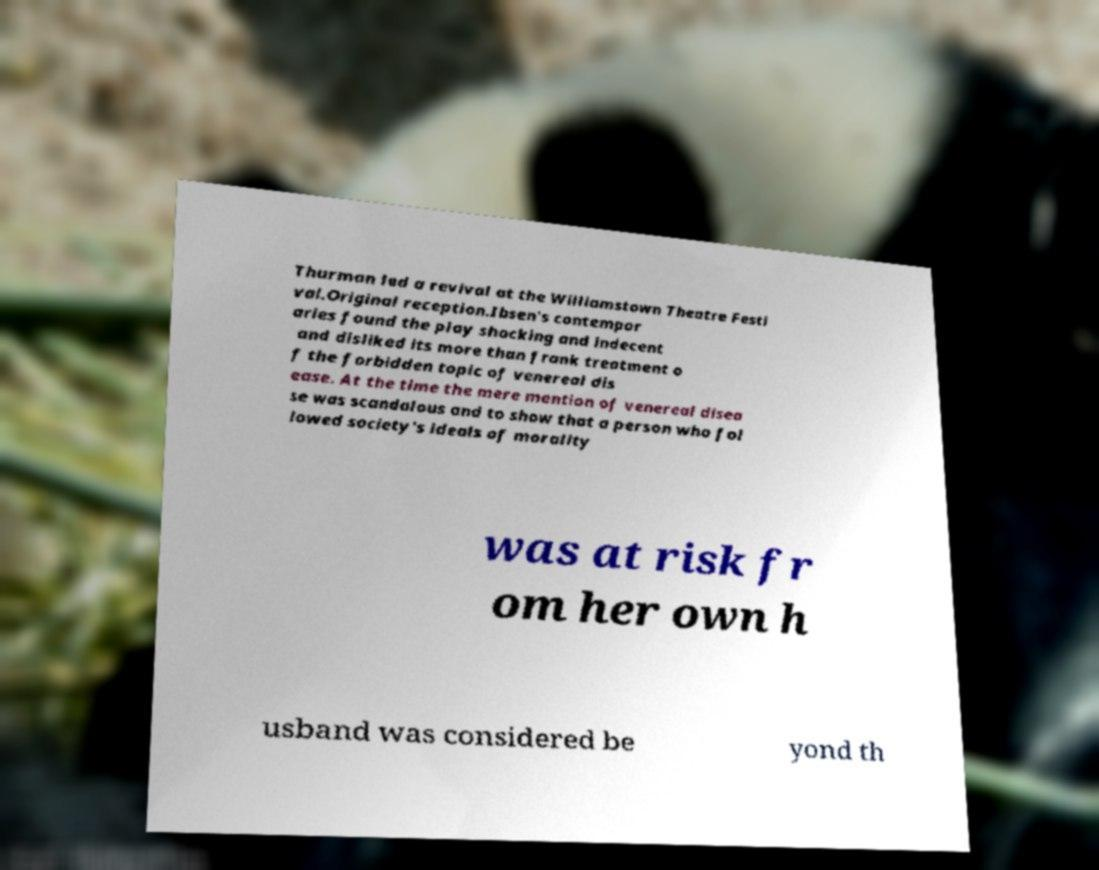Can you accurately transcribe the text from the provided image for me? Thurman led a revival at the Williamstown Theatre Festi val.Original reception.Ibsen's contempor aries found the play shocking and indecent and disliked its more than frank treatment o f the forbidden topic of venereal dis ease. At the time the mere mention of venereal disea se was scandalous and to show that a person who fol lowed society's ideals of morality was at risk fr om her own h usband was considered be yond th 